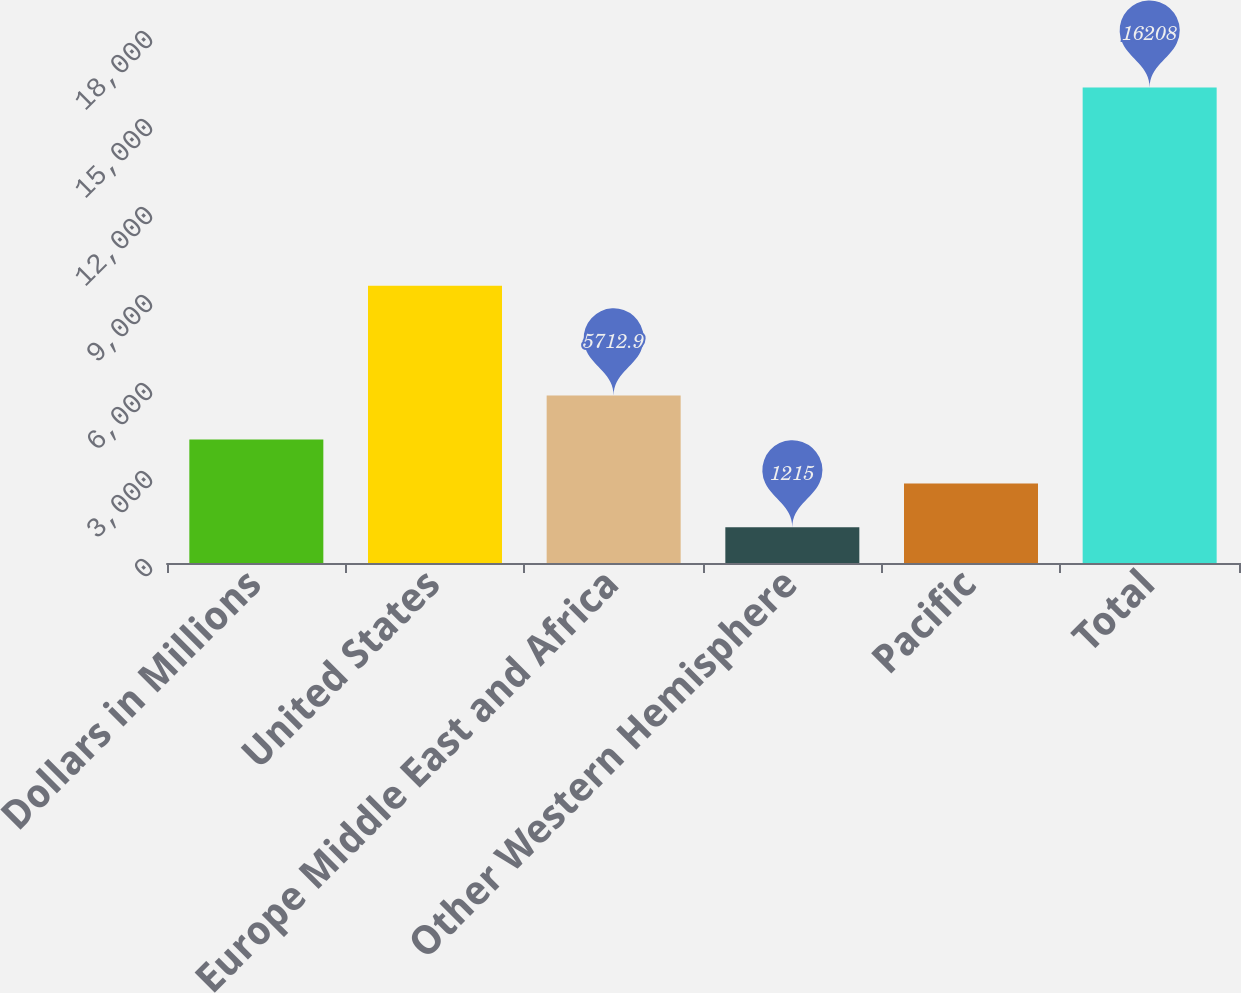Convert chart. <chart><loc_0><loc_0><loc_500><loc_500><bar_chart><fcel>Dollars in Millions<fcel>United States<fcel>Europe Middle East and Africa<fcel>Other Western Hemisphere<fcel>Pacific<fcel>Total<nl><fcel>4213.6<fcel>9450<fcel>5712.9<fcel>1215<fcel>2714.3<fcel>16208<nl></chart> 